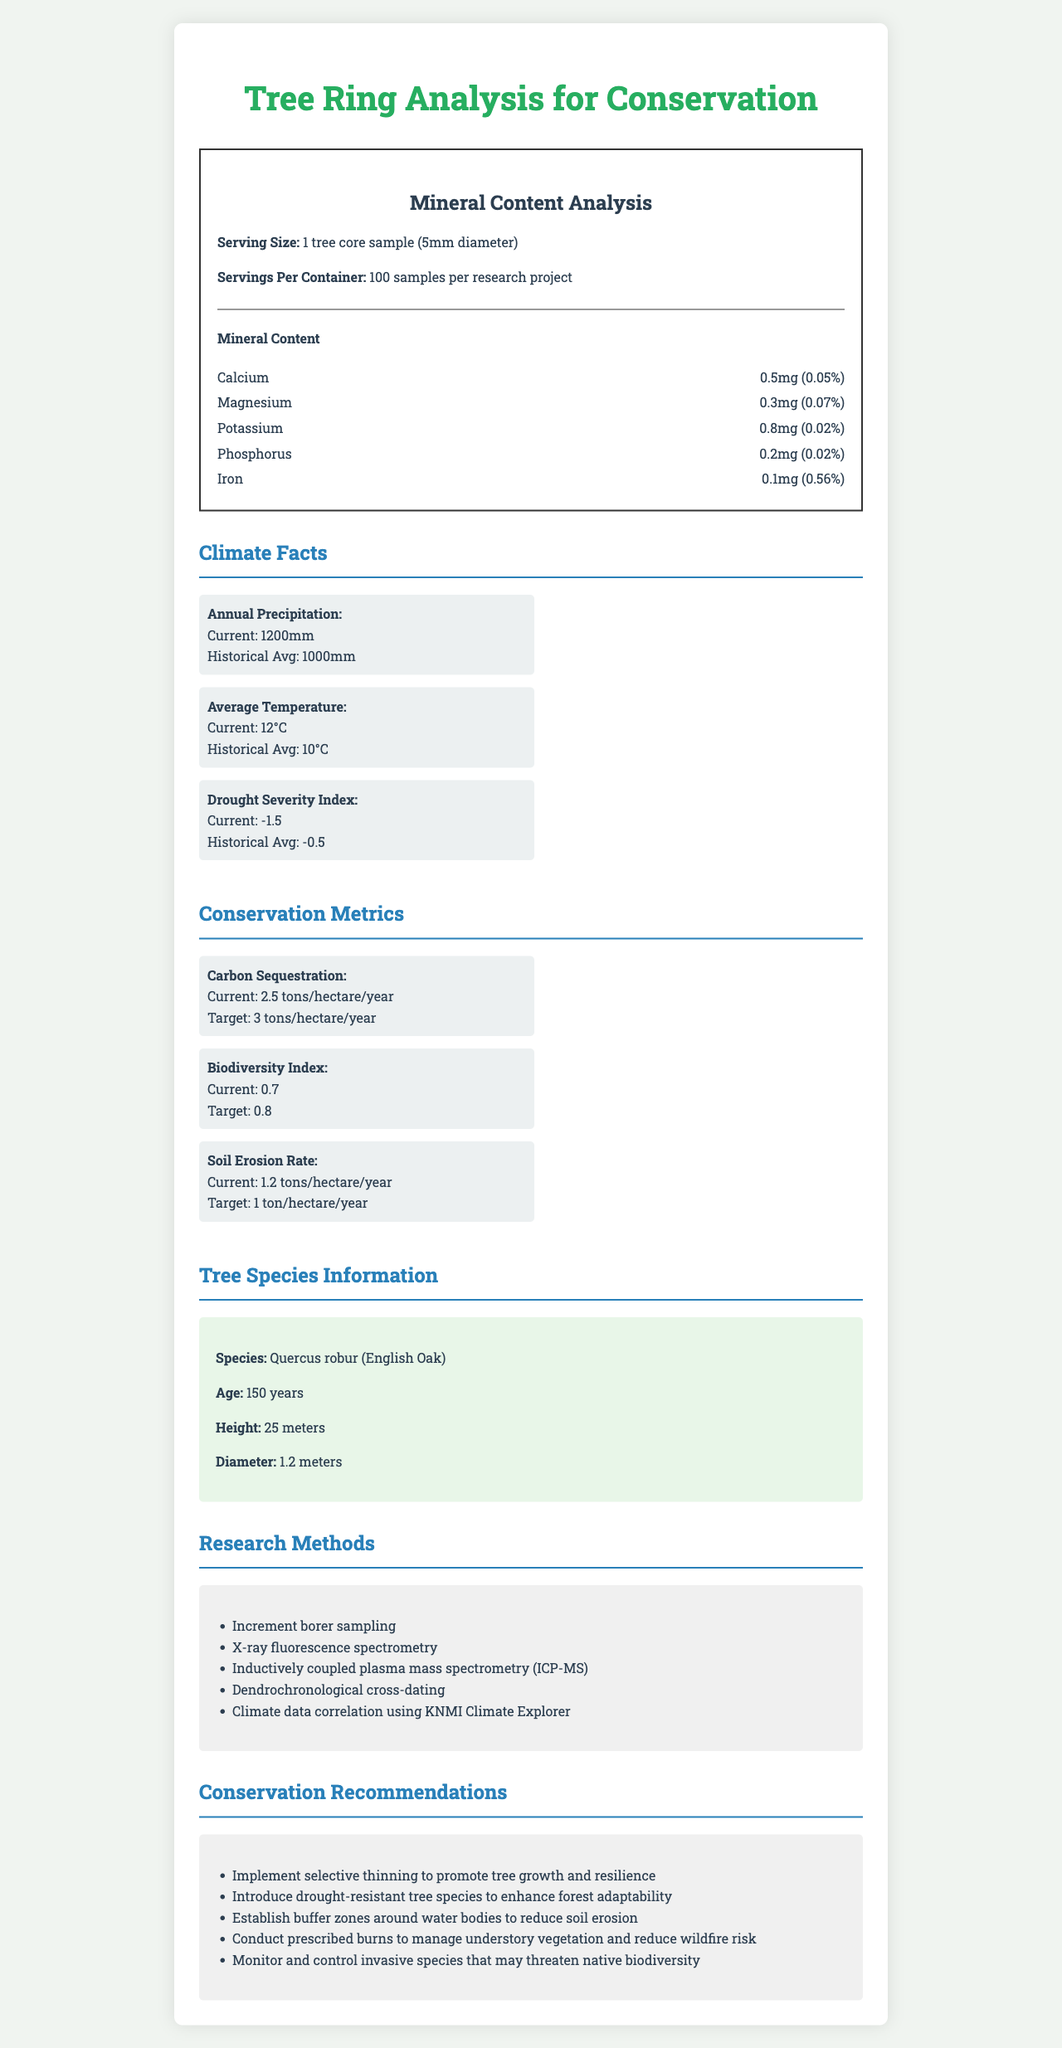what is the serving size for the mineral content analysis? The document clearly states that the serving size is "1 tree core sample (5mm diameter)".
Answer: 1 tree core sample (5mm diameter) what is the historical average of annual precipitation? The document under the "Climate Facts" section shows the historical average of annual precipitation as "1000mm".
Answer: 1000mm which mineral has the highest daily value percentage? The document lists Iron with a daily value of 0.56%, which is the highest among the minerals mentioned.
Answer: Iron how many research methods are listed? The document specifies five research methods: Increment borer sampling, X-ray fluorescence spectrometry, Inductively coupled plasma mass spectrometry (ICP-MS), Dendrochronological cross-dating, and Climate data correlation using KNMI Climate Explorer.
Answer: Five what is the current Drought Severity Index? The document under the "Climate Facts" section shows the current Drought Severity Index as -1.5.
Answer: -1.5 how many tree core samples are typically examined in a research project? The document states that there are 100 samples per research project under the nutritional label section.
Answer: 100 samples per research project which metric is closest to reaching its target? A. Carbon Sequestration B. Biodiversity Index C. Soil Erosion Rate The Carbon Sequestration amount is 2.5 tons/hectare/year with a target of 3 tons/hectare/year, while the Biodiversity Index is 0.7 with a target of 0.8 and the Soil Erosion Rate is 1.2 tons/hectare/year with a target of 1 ton/hectare/year. Carbon Sequestration is closest to its target.
Answer: A. Carbon Sequestration what is the current average temperature compared to the historical average? The document lists the current average temperature as 12°C and the historical average as 10°C, indicating a 2°C increase.
Answer: The current average temperature is 12°C, which is 2°C higher than the historical average of 10°C. which method is NOT used in the research? A. Increment Borer Sampling B. X-ray Fluorescence Spectrometry C. Genetic Sequencing D. Climate Data Correlation Using KNMI Climate Explorer The document lists various methods used in the research, but Genetic Sequencing is not one of them.
Answer: C. Genetic Sequencing does the height of the Quercus robur tree exceed 20 meters? The document specifies that the height of the Quercus robur (English Oak) is 25 meters, which exceeds 20 meters.
Answer: Yes describe the main focus of this document The document integrates various data points such as mineral content and climate facts, using research methods to derive insights, and finally presents conservation metrics and actionable recommendations to improve forest conservation and resilience.
Answer: The document focuses on the analysis of tree ring data, specifically mineral content in tree rings, and how it correlates with historical climate data. It also outlines conservation metrics, tree species information, research methods, and provides conservation recommendations. is the Carbon Sequestration rate improving over the target? The document indicates that the current Carbon Sequestration rate is 2.5 tons/hectare/year, while the target is 3 tons/hectare/year, showing that it is currently below the desired target.
Answer: No, it is below the target. what is the Iron content in one tree core sample? According to the document, the Iron content in one tree core sample is 0.1mg.
Answer: 0.1mg what type of oak is mentioned in the tree species information? The document specifies the tree species as Quercus robur, commonly known as English Oak.
Answer: Quercus robur (English Oak) how is drought severity indexed? The document shows the Drought Severity Index under the "Climate Facts" section, where the current value is -1.5.
Answer: With a Drought Severity Index value of -1.5 what is the target amount of the Biodiversity Index for conservation planning? The document states that the target amount for the Biodiversity Index is 0.8 under the conservation metrics section.
Answer: 0.8 did the document mention the soil pH values? The document provided does not include any information regarding soil pH values.
Answer: Not enough information 